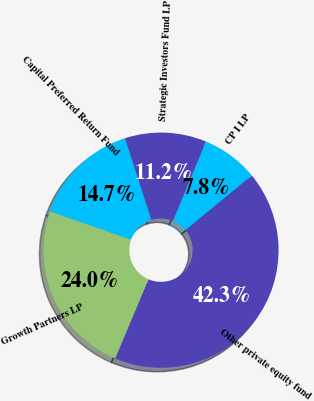Convert chart. <chart><loc_0><loc_0><loc_500><loc_500><pie_chart><fcel>Strategic Investors Fund LP<fcel>Capital Preferred Return Fund<fcel>Growth Partners LP<fcel>Other private equity fund<fcel>CP I LP<nl><fcel>11.23%<fcel>14.69%<fcel>23.99%<fcel>42.31%<fcel>7.78%<nl></chart> 